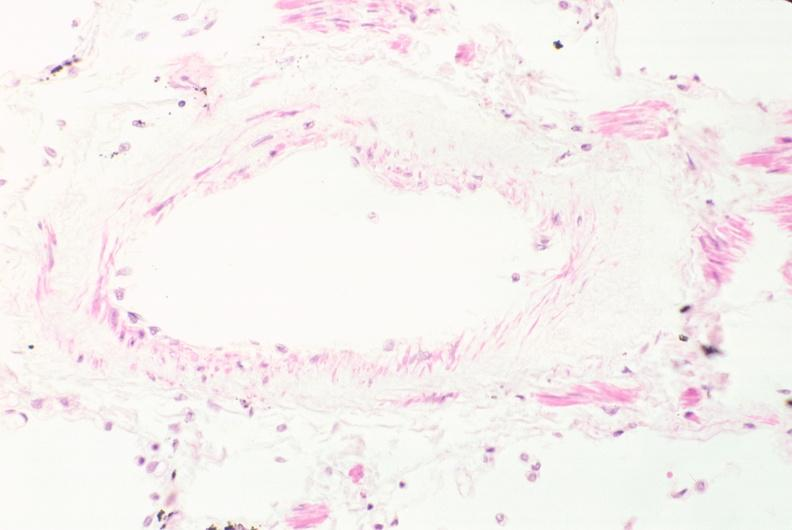s respiratory present?
Answer the question using a single word or phrase. Yes 